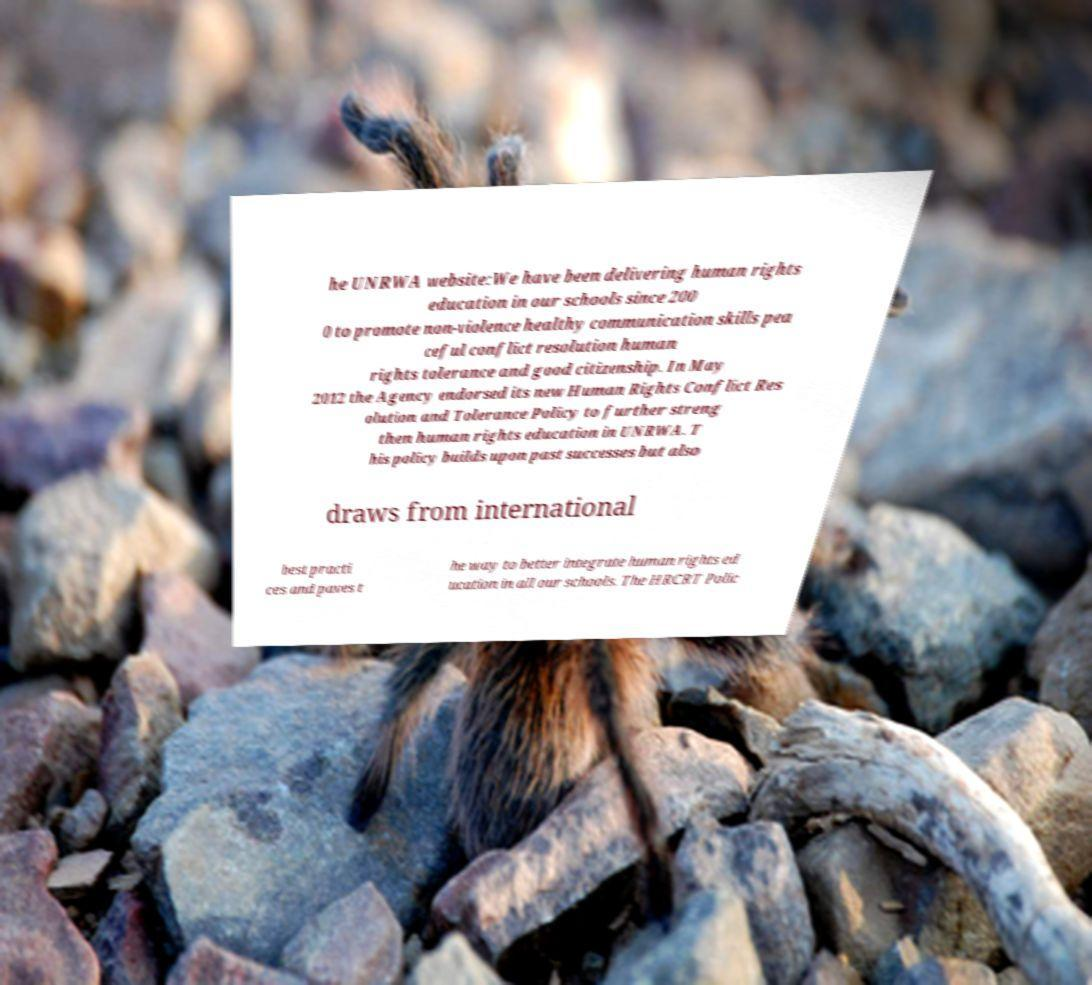Can you accurately transcribe the text from the provided image for me? he UNRWA website:We have been delivering human rights education in our schools since 200 0 to promote non-violence healthy communication skills pea ceful conflict resolution human rights tolerance and good citizenship. In May 2012 the Agency endorsed its new Human Rights Conflict Res olution and Tolerance Policy to further streng then human rights education in UNRWA. T his policy builds upon past successes but also draws from international best practi ces and paves t he way to better integrate human rights ed ucation in all our schools. The HRCRT Polic 